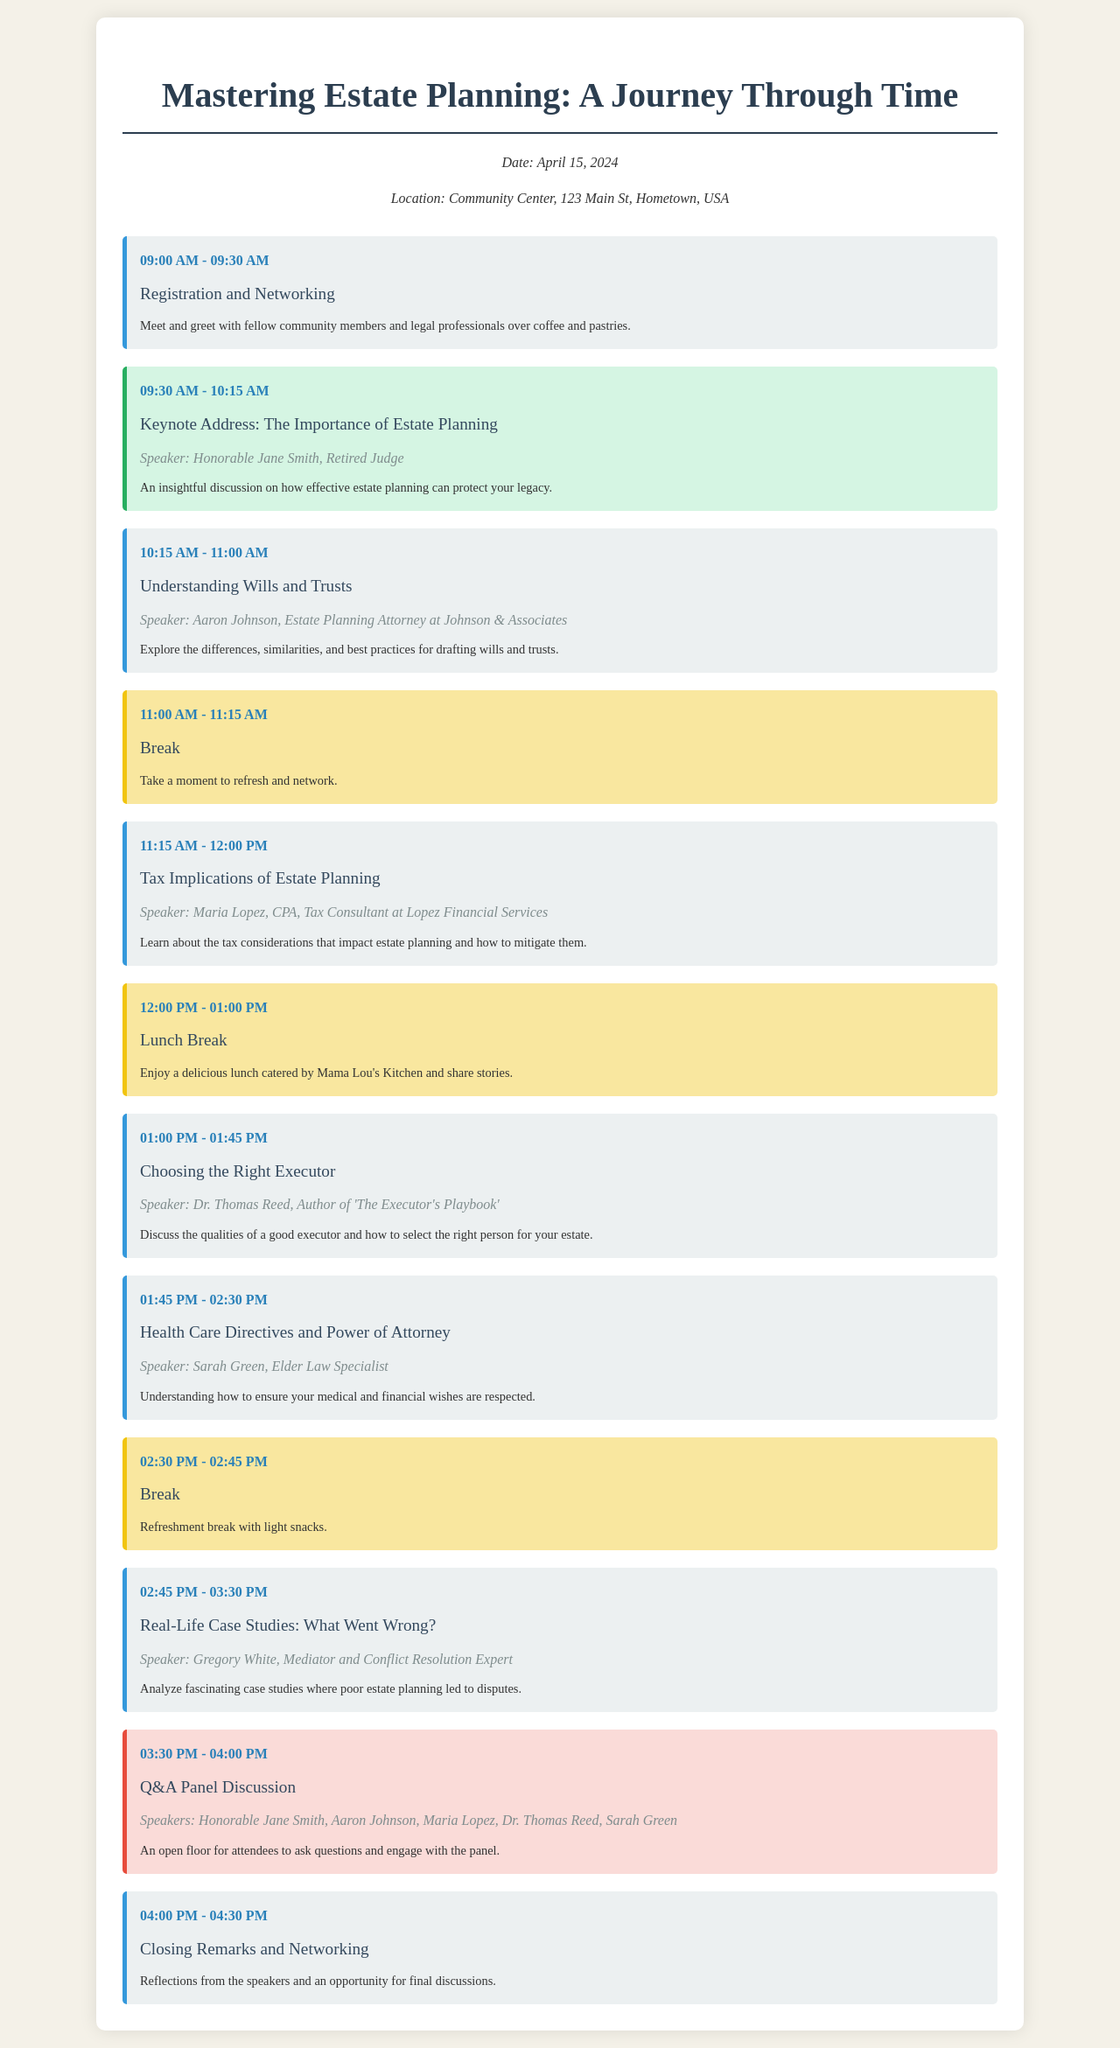What is the date of the seminar? The date of the seminar is explicitly stated in the document.
Answer: April 15, 2024 What is the location of the seminar? The location information is provided clearly in the seminar info section.
Answer: Community Center, 123 Main St, Hometown, USA Who is the keynote speaker? The keynote address section includes the name of the speaker.
Answer: Honorable Jane Smith What time does the seminar start? The opening event listed gives the start time of the seminar.
Answer: 09:00 AM What session discusses tax implications? The session focusing on taxes is specified in the agenda with its title.
Answer: Tax Implications of Estate Planning Which session involves a Q&A panel discussion? The agenda includes a title for the panel discussion with speakers listed.
Answer: Q&A Panel Discussion How long is the lunch break? The schedule mentions the duration of the lunch break in the document.
Answer: One hour Who is the speaker for health care directives? The speaker associated with this topic is mentioned in the agenda.
Answer: Sarah Green What time does the seminar conclude? The last session indicates the conclusion time of the seminar.
Answer: 04:30 PM 